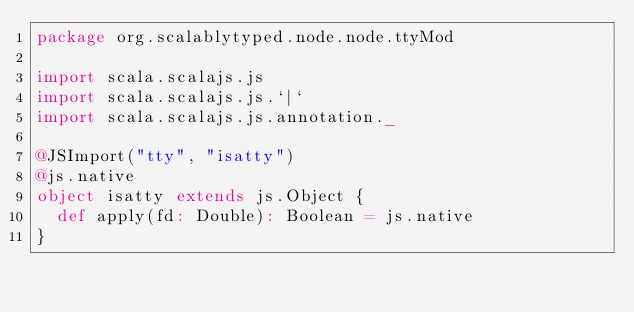<code> <loc_0><loc_0><loc_500><loc_500><_Scala_>package org.scalablytyped.node.node.ttyMod

import scala.scalajs.js
import scala.scalajs.js.`|`
import scala.scalajs.js.annotation._

@JSImport("tty", "isatty")
@js.native
object isatty extends js.Object {
  def apply(fd: Double): Boolean = js.native
}

</code> 